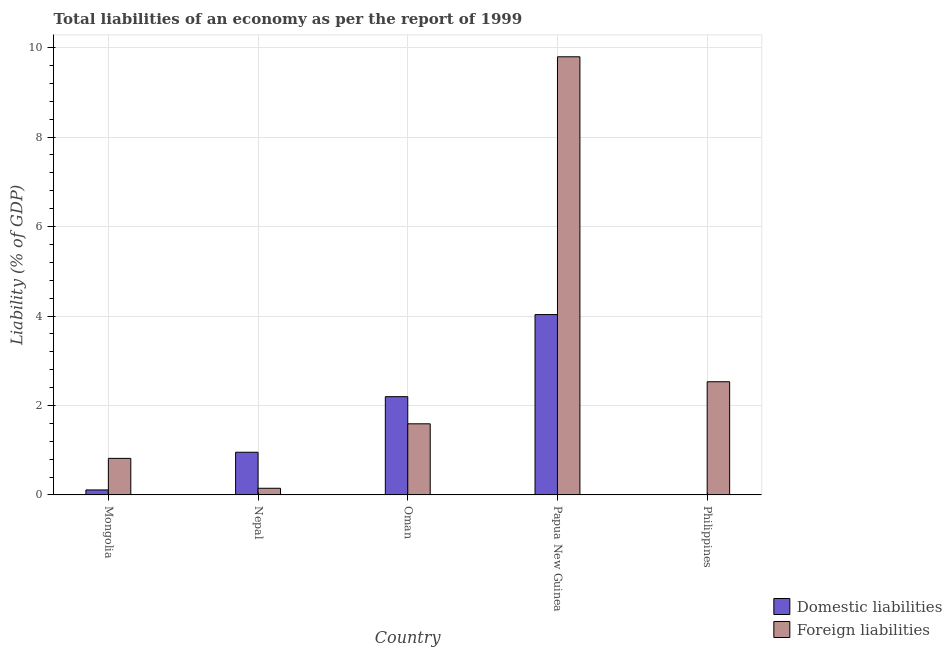What is the label of the 2nd group of bars from the left?
Keep it short and to the point. Nepal. In how many cases, is the number of bars for a given country not equal to the number of legend labels?
Offer a very short reply. 1. What is the incurrence of foreign liabilities in Nepal?
Make the answer very short. 0.15. Across all countries, what is the maximum incurrence of domestic liabilities?
Your response must be concise. 4.03. Across all countries, what is the minimum incurrence of foreign liabilities?
Provide a succinct answer. 0.15. In which country was the incurrence of domestic liabilities maximum?
Make the answer very short. Papua New Guinea. What is the total incurrence of foreign liabilities in the graph?
Make the answer very short. 14.88. What is the difference between the incurrence of foreign liabilities in Mongolia and that in Oman?
Give a very brief answer. -0.77. What is the difference between the incurrence of domestic liabilities in Philippines and the incurrence of foreign liabilities in Papua New Guinea?
Provide a succinct answer. -9.79. What is the average incurrence of foreign liabilities per country?
Your response must be concise. 2.98. What is the difference between the incurrence of foreign liabilities and incurrence of domestic liabilities in Papua New Guinea?
Provide a succinct answer. 5.76. What is the ratio of the incurrence of foreign liabilities in Mongolia to that in Nepal?
Your answer should be compact. 5.49. Is the difference between the incurrence of foreign liabilities in Mongolia and Nepal greater than the difference between the incurrence of domestic liabilities in Mongolia and Nepal?
Keep it short and to the point. Yes. What is the difference between the highest and the second highest incurrence of foreign liabilities?
Offer a terse response. 7.26. What is the difference between the highest and the lowest incurrence of domestic liabilities?
Offer a very short reply. 4.03. In how many countries, is the incurrence of domestic liabilities greater than the average incurrence of domestic liabilities taken over all countries?
Ensure brevity in your answer.  2. How many countries are there in the graph?
Ensure brevity in your answer.  5. Are the values on the major ticks of Y-axis written in scientific E-notation?
Your response must be concise. No. How are the legend labels stacked?
Provide a succinct answer. Vertical. What is the title of the graph?
Provide a succinct answer. Total liabilities of an economy as per the report of 1999. What is the label or title of the X-axis?
Your answer should be very brief. Country. What is the label or title of the Y-axis?
Provide a succinct answer. Liability (% of GDP). What is the Liability (% of GDP) of Domestic liabilities in Mongolia?
Your answer should be compact. 0.11. What is the Liability (% of GDP) of Foreign liabilities in Mongolia?
Provide a short and direct response. 0.82. What is the Liability (% of GDP) of Domestic liabilities in Nepal?
Provide a short and direct response. 0.95. What is the Liability (% of GDP) of Foreign liabilities in Nepal?
Make the answer very short. 0.15. What is the Liability (% of GDP) of Domestic liabilities in Oman?
Ensure brevity in your answer.  2.2. What is the Liability (% of GDP) in Foreign liabilities in Oman?
Provide a succinct answer. 1.59. What is the Liability (% of GDP) of Domestic liabilities in Papua New Guinea?
Your answer should be compact. 4.03. What is the Liability (% of GDP) of Foreign liabilities in Papua New Guinea?
Your response must be concise. 9.79. What is the Liability (% of GDP) in Foreign liabilities in Philippines?
Your answer should be very brief. 2.53. Across all countries, what is the maximum Liability (% of GDP) in Domestic liabilities?
Make the answer very short. 4.03. Across all countries, what is the maximum Liability (% of GDP) of Foreign liabilities?
Keep it short and to the point. 9.79. Across all countries, what is the minimum Liability (% of GDP) in Domestic liabilities?
Your response must be concise. 0. Across all countries, what is the minimum Liability (% of GDP) of Foreign liabilities?
Your response must be concise. 0.15. What is the total Liability (% of GDP) of Domestic liabilities in the graph?
Your response must be concise. 7.29. What is the total Liability (% of GDP) in Foreign liabilities in the graph?
Provide a short and direct response. 14.88. What is the difference between the Liability (% of GDP) in Domestic liabilities in Mongolia and that in Nepal?
Your answer should be very brief. -0.84. What is the difference between the Liability (% of GDP) in Foreign liabilities in Mongolia and that in Nepal?
Ensure brevity in your answer.  0.67. What is the difference between the Liability (% of GDP) of Domestic liabilities in Mongolia and that in Oman?
Keep it short and to the point. -2.09. What is the difference between the Liability (% of GDP) of Foreign liabilities in Mongolia and that in Oman?
Make the answer very short. -0.77. What is the difference between the Liability (% of GDP) in Domestic liabilities in Mongolia and that in Papua New Guinea?
Provide a short and direct response. -3.92. What is the difference between the Liability (% of GDP) in Foreign liabilities in Mongolia and that in Papua New Guinea?
Your answer should be compact. -8.98. What is the difference between the Liability (% of GDP) of Foreign liabilities in Mongolia and that in Philippines?
Provide a short and direct response. -1.71. What is the difference between the Liability (% of GDP) of Domestic liabilities in Nepal and that in Oman?
Provide a short and direct response. -1.24. What is the difference between the Liability (% of GDP) of Foreign liabilities in Nepal and that in Oman?
Provide a succinct answer. -1.44. What is the difference between the Liability (% of GDP) of Domestic liabilities in Nepal and that in Papua New Guinea?
Provide a succinct answer. -3.08. What is the difference between the Liability (% of GDP) in Foreign liabilities in Nepal and that in Papua New Guinea?
Make the answer very short. -9.65. What is the difference between the Liability (% of GDP) of Foreign liabilities in Nepal and that in Philippines?
Your answer should be compact. -2.38. What is the difference between the Liability (% of GDP) in Domestic liabilities in Oman and that in Papua New Guinea?
Ensure brevity in your answer.  -1.83. What is the difference between the Liability (% of GDP) in Foreign liabilities in Oman and that in Papua New Guinea?
Your answer should be very brief. -8.2. What is the difference between the Liability (% of GDP) of Foreign liabilities in Oman and that in Philippines?
Ensure brevity in your answer.  -0.94. What is the difference between the Liability (% of GDP) of Foreign liabilities in Papua New Guinea and that in Philippines?
Ensure brevity in your answer.  7.26. What is the difference between the Liability (% of GDP) in Domestic liabilities in Mongolia and the Liability (% of GDP) in Foreign liabilities in Nepal?
Offer a terse response. -0.04. What is the difference between the Liability (% of GDP) in Domestic liabilities in Mongolia and the Liability (% of GDP) in Foreign liabilities in Oman?
Keep it short and to the point. -1.48. What is the difference between the Liability (% of GDP) in Domestic liabilities in Mongolia and the Liability (% of GDP) in Foreign liabilities in Papua New Guinea?
Ensure brevity in your answer.  -9.68. What is the difference between the Liability (% of GDP) of Domestic liabilities in Mongolia and the Liability (% of GDP) of Foreign liabilities in Philippines?
Provide a short and direct response. -2.42. What is the difference between the Liability (% of GDP) of Domestic liabilities in Nepal and the Liability (% of GDP) of Foreign liabilities in Oman?
Your answer should be compact. -0.64. What is the difference between the Liability (% of GDP) in Domestic liabilities in Nepal and the Liability (% of GDP) in Foreign liabilities in Papua New Guinea?
Make the answer very short. -8.84. What is the difference between the Liability (% of GDP) in Domestic liabilities in Nepal and the Liability (% of GDP) in Foreign liabilities in Philippines?
Your answer should be very brief. -1.58. What is the difference between the Liability (% of GDP) of Domestic liabilities in Oman and the Liability (% of GDP) of Foreign liabilities in Papua New Guinea?
Provide a short and direct response. -7.6. What is the difference between the Liability (% of GDP) of Domestic liabilities in Oman and the Liability (% of GDP) of Foreign liabilities in Philippines?
Give a very brief answer. -0.33. What is the difference between the Liability (% of GDP) of Domestic liabilities in Papua New Guinea and the Liability (% of GDP) of Foreign liabilities in Philippines?
Keep it short and to the point. 1.5. What is the average Liability (% of GDP) of Domestic liabilities per country?
Ensure brevity in your answer.  1.46. What is the average Liability (% of GDP) of Foreign liabilities per country?
Offer a terse response. 2.98. What is the difference between the Liability (% of GDP) in Domestic liabilities and Liability (% of GDP) in Foreign liabilities in Mongolia?
Ensure brevity in your answer.  -0.71. What is the difference between the Liability (% of GDP) in Domestic liabilities and Liability (% of GDP) in Foreign liabilities in Nepal?
Provide a succinct answer. 0.81. What is the difference between the Liability (% of GDP) in Domestic liabilities and Liability (% of GDP) in Foreign liabilities in Oman?
Provide a succinct answer. 0.61. What is the difference between the Liability (% of GDP) in Domestic liabilities and Liability (% of GDP) in Foreign liabilities in Papua New Guinea?
Give a very brief answer. -5.76. What is the ratio of the Liability (% of GDP) of Domestic liabilities in Mongolia to that in Nepal?
Your answer should be very brief. 0.12. What is the ratio of the Liability (% of GDP) of Foreign liabilities in Mongolia to that in Nepal?
Offer a terse response. 5.49. What is the ratio of the Liability (% of GDP) of Domestic liabilities in Mongolia to that in Oman?
Ensure brevity in your answer.  0.05. What is the ratio of the Liability (% of GDP) of Foreign liabilities in Mongolia to that in Oman?
Give a very brief answer. 0.51. What is the ratio of the Liability (% of GDP) of Domestic liabilities in Mongolia to that in Papua New Guinea?
Your response must be concise. 0.03. What is the ratio of the Liability (% of GDP) of Foreign liabilities in Mongolia to that in Papua New Guinea?
Your response must be concise. 0.08. What is the ratio of the Liability (% of GDP) in Foreign liabilities in Mongolia to that in Philippines?
Give a very brief answer. 0.32. What is the ratio of the Liability (% of GDP) in Domestic liabilities in Nepal to that in Oman?
Your answer should be very brief. 0.43. What is the ratio of the Liability (% of GDP) of Foreign liabilities in Nepal to that in Oman?
Offer a very short reply. 0.09. What is the ratio of the Liability (% of GDP) of Domestic liabilities in Nepal to that in Papua New Guinea?
Provide a short and direct response. 0.24. What is the ratio of the Liability (% of GDP) of Foreign liabilities in Nepal to that in Papua New Guinea?
Make the answer very short. 0.02. What is the ratio of the Liability (% of GDP) in Foreign liabilities in Nepal to that in Philippines?
Offer a very short reply. 0.06. What is the ratio of the Liability (% of GDP) of Domestic liabilities in Oman to that in Papua New Guinea?
Provide a succinct answer. 0.54. What is the ratio of the Liability (% of GDP) of Foreign liabilities in Oman to that in Papua New Guinea?
Offer a very short reply. 0.16. What is the ratio of the Liability (% of GDP) in Foreign liabilities in Oman to that in Philippines?
Keep it short and to the point. 0.63. What is the ratio of the Liability (% of GDP) in Foreign liabilities in Papua New Guinea to that in Philippines?
Your response must be concise. 3.87. What is the difference between the highest and the second highest Liability (% of GDP) of Domestic liabilities?
Your response must be concise. 1.83. What is the difference between the highest and the second highest Liability (% of GDP) in Foreign liabilities?
Keep it short and to the point. 7.26. What is the difference between the highest and the lowest Liability (% of GDP) of Domestic liabilities?
Offer a terse response. 4.03. What is the difference between the highest and the lowest Liability (% of GDP) of Foreign liabilities?
Ensure brevity in your answer.  9.65. 